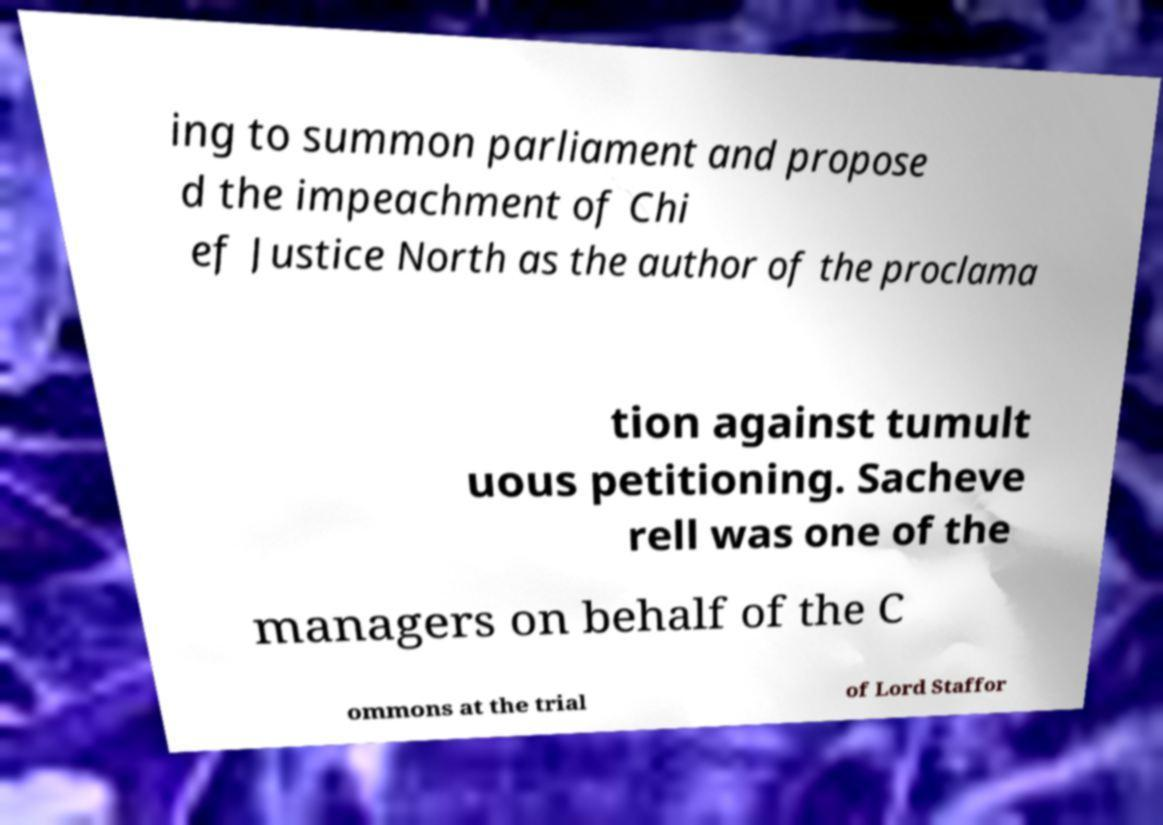What messages or text are displayed in this image? I need them in a readable, typed format. ing to summon parliament and propose d the impeachment of Chi ef Justice North as the author of the proclama tion against tumult uous petitioning. Sacheve rell was one of the managers on behalf of the C ommons at the trial of Lord Staffor 